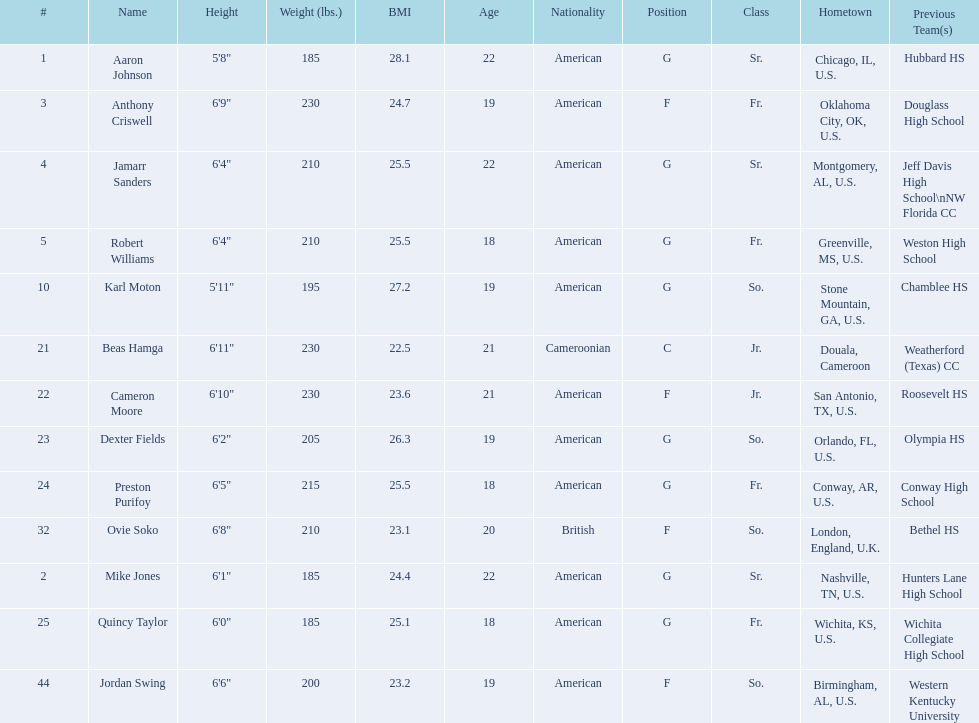How many players come from alabama? 2. Write the full table. {'header': ['#', 'Name', 'Height', 'Weight (lbs.)', 'BMI', 'Age', 'Nationality', 'Position', 'Class', 'Hometown', 'Previous Team(s)'], 'rows': [['1', 'Aaron Johnson', '5\'8"', '185', '28.1', '22', 'American', 'G', 'Sr.', 'Chicago, IL, U.S.', 'Hubbard HS'], ['3', 'Anthony Criswell', '6\'9"', '230', '24.7', '19', 'American', 'F', 'Fr.', 'Oklahoma City, OK, U.S.', 'Douglass High School'], ['4', 'Jamarr Sanders', '6\'4"', '210', '25.5', '22', 'American', 'G', 'Sr.', 'Montgomery, AL, U.S.', 'Jeff Davis High School\\nNW Florida CC'], ['5', 'Robert Williams', '6\'4"', '210', '25.5', '18', 'American', 'G', 'Fr.', 'Greenville, MS, U.S.', 'Weston High School'], ['10', 'Karl Moton', '5\'11"', '195', '27.2', '19', 'American', 'G', 'So.', 'Stone Mountain, GA, U.S.', 'Chamblee HS'], ['21', 'Beas Hamga', '6\'11"', '230', '22.5', '21', 'Cameroonian', 'C', 'Jr.', 'Douala, Cameroon', 'Weatherford (Texas) CC'], ['22', 'Cameron Moore', '6\'10"', '230', '23.6', '21', 'American', 'F', 'Jr.', 'San Antonio, TX, U.S.', 'Roosevelt HS'], ['23', 'Dexter Fields', '6\'2"', '205', '26.3', '19', 'American', 'G', 'So.', 'Orlando, FL, U.S.', 'Olympia HS'], ['24', 'Preston Purifoy', '6\'5"', '215', '25.5', '18', 'American', 'G', 'Fr.', 'Conway, AR, U.S.', 'Conway High School'], ['32', 'Ovie Soko', '6\'8"', '210', '23.1', '20', 'British', 'F', 'So.', 'London, England, U.K.', 'Bethel HS'], ['2', 'Mike Jones', '6\'1"', '185', '24.4', '22', 'American', 'G', 'Sr.', 'Nashville, TN, U.S.', 'Hunters Lane High School'], ['25', 'Quincy Taylor', '6\'0"', '185', '25.1', '18', 'American', 'G', 'Fr.', 'Wichita, KS, U.S.', 'Wichita Collegiate High School'], ['44', 'Jordan Swing', '6\'6"', '200', '23.2', '19', 'American', 'F', 'So.', 'Birmingham, AL, U.S.', 'Western Kentucky University']]} 